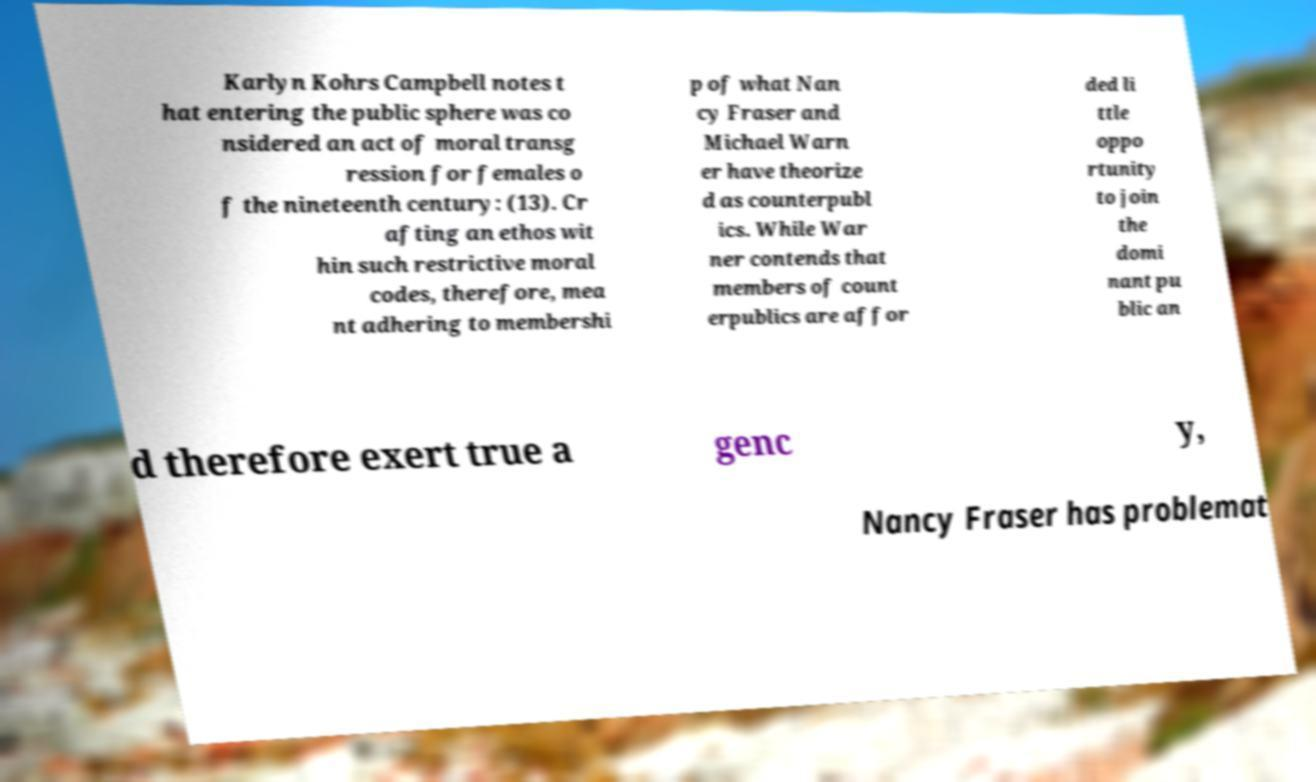Please read and relay the text visible in this image. What does it say? Karlyn Kohrs Campbell notes t hat entering the public sphere was co nsidered an act of moral transg ression for females o f the nineteenth century: (13). Cr afting an ethos wit hin such restrictive moral codes, therefore, mea nt adhering to membershi p of what Nan cy Fraser and Michael Warn er have theorize d as counterpubl ics. While War ner contends that members of count erpublics are affor ded li ttle oppo rtunity to join the domi nant pu blic an d therefore exert true a genc y, Nancy Fraser has problemat 